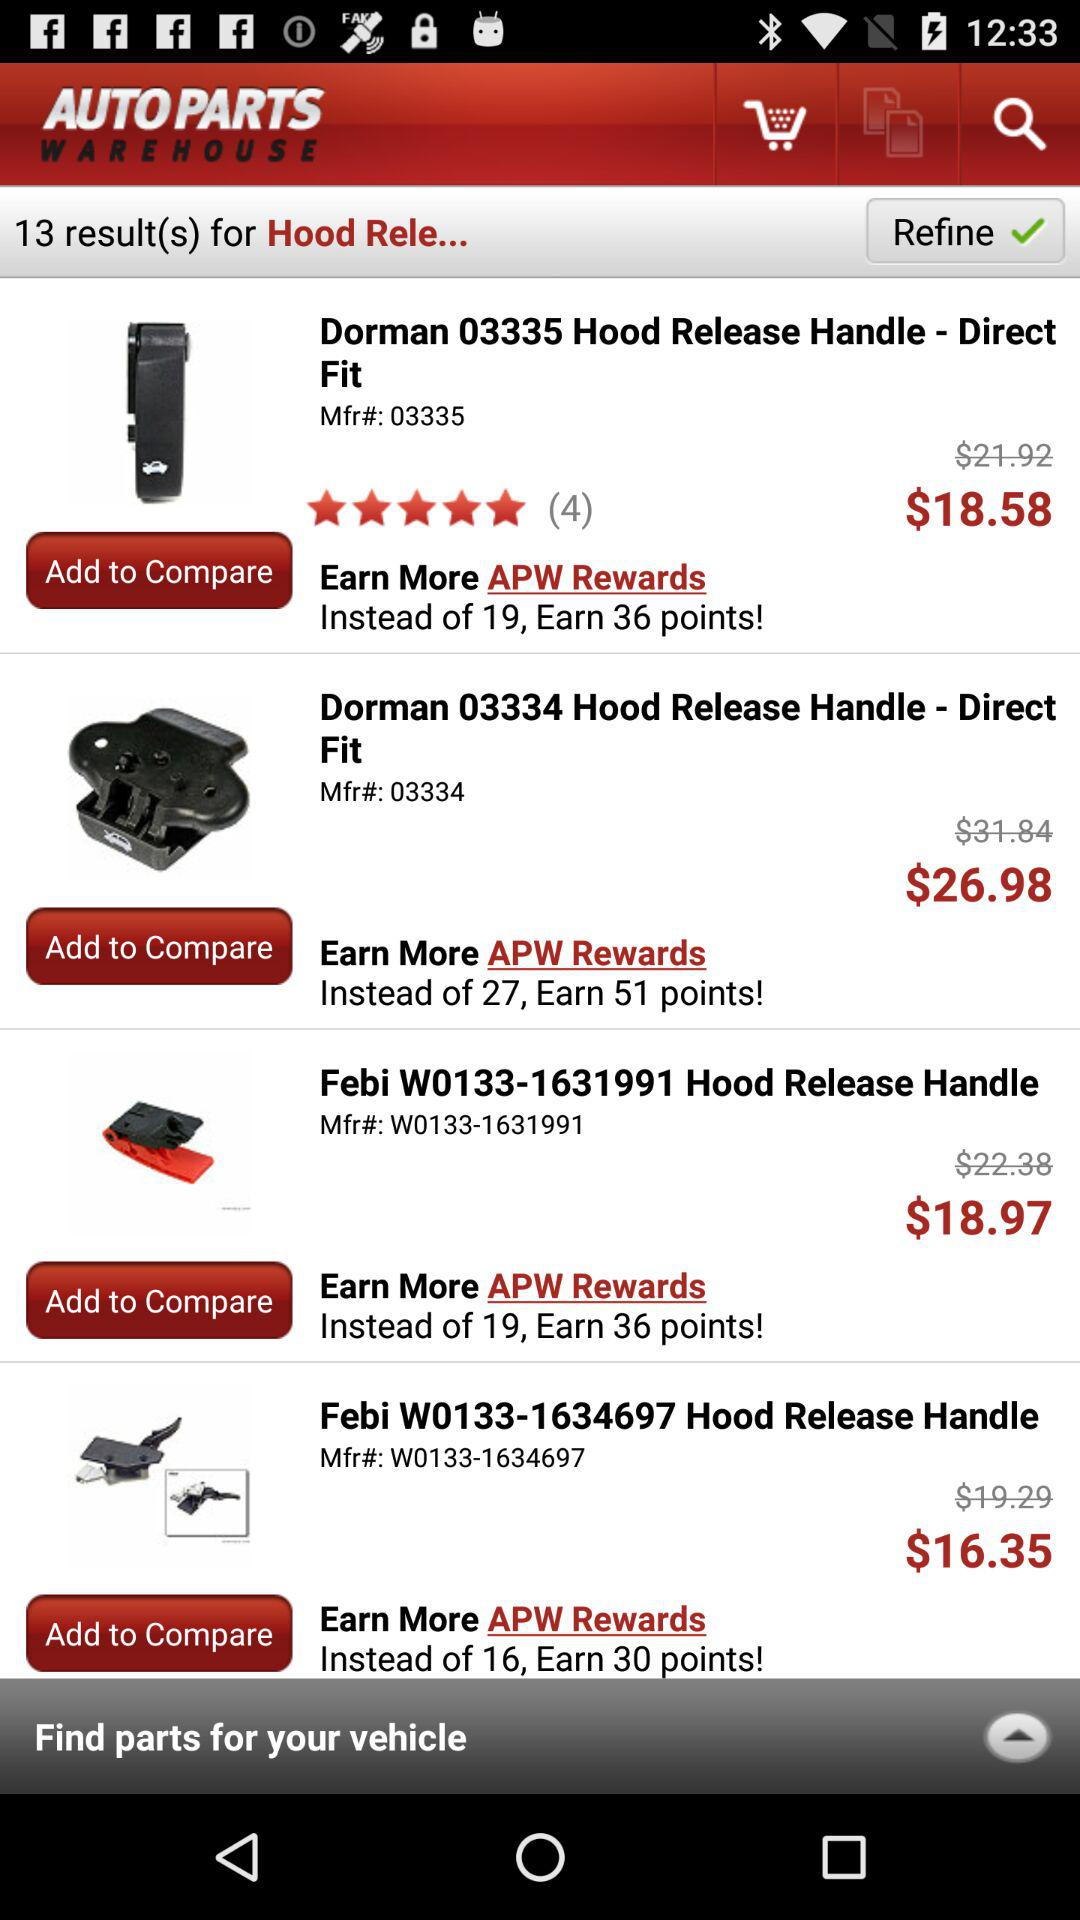How many results were found? There were 13 found results. 